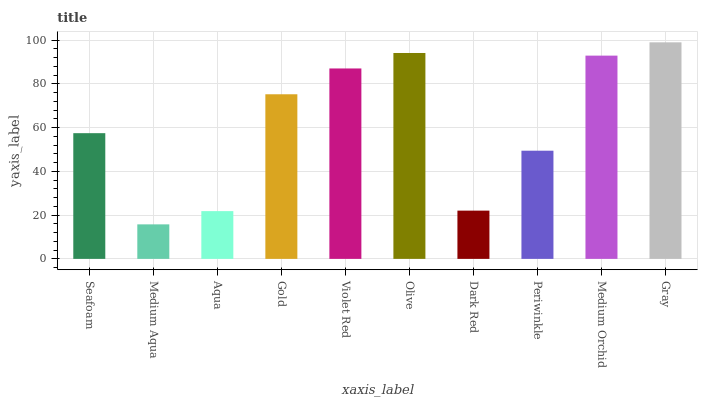Is Medium Aqua the minimum?
Answer yes or no. Yes. Is Gray the maximum?
Answer yes or no. Yes. Is Aqua the minimum?
Answer yes or no. No. Is Aqua the maximum?
Answer yes or no. No. Is Aqua greater than Medium Aqua?
Answer yes or no. Yes. Is Medium Aqua less than Aqua?
Answer yes or no. Yes. Is Medium Aqua greater than Aqua?
Answer yes or no. No. Is Aqua less than Medium Aqua?
Answer yes or no. No. Is Gold the high median?
Answer yes or no. Yes. Is Seafoam the low median?
Answer yes or no. Yes. Is Medium Orchid the high median?
Answer yes or no. No. Is Medium Aqua the low median?
Answer yes or no. No. 